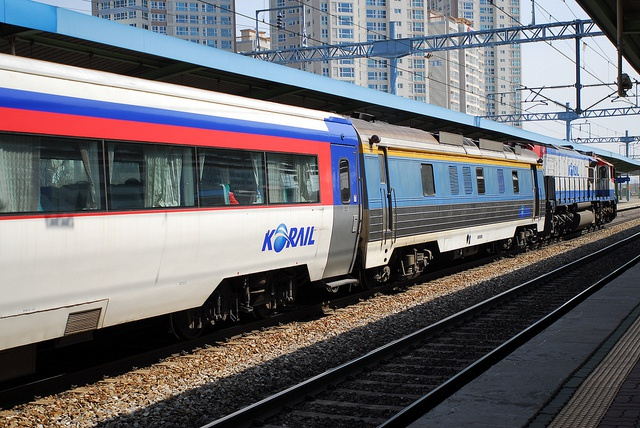Describe the objects in this image and their specific colors. I can see train in lightblue, lightgray, black, gray, and darkgray tones and people in lightblue, black, darkblue, teal, and salmon tones in this image. 